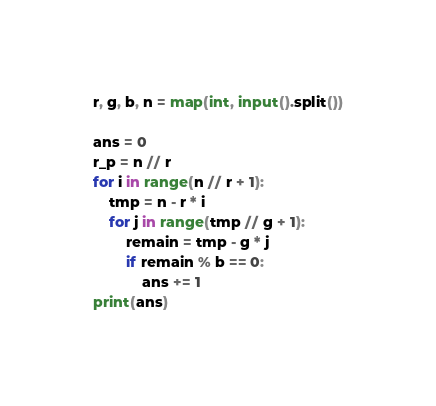Convert code to text. <code><loc_0><loc_0><loc_500><loc_500><_Python_>r, g, b, n = map(int, input().split())

ans = 0
r_p = n // r
for i in range(n // r + 1):
    tmp = n - r * i
    for j in range(tmp // g + 1):
        remain = tmp - g * j
        if remain % b == 0:
            ans += 1
print(ans)
</code> 